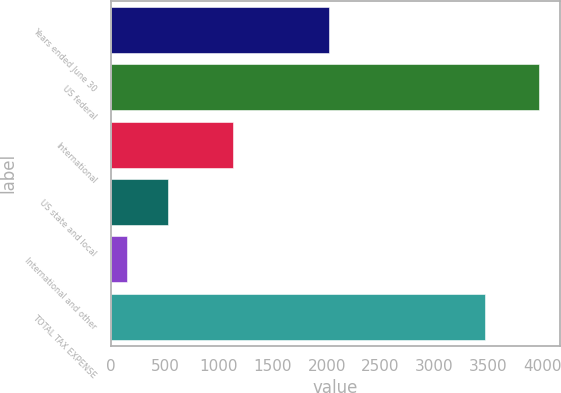Convert chart. <chart><loc_0><loc_0><loc_500><loc_500><bar_chart><fcel>Years ended June 30<fcel>US federal<fcel>International<fcel>US state and local<fcel>International and other<fcel>TOTAL TAX EXPENSE<nl><fcel>2018<fcel>3965<fcel>1131<fcel>527<fcel>145<fcel>3465<nl></chart> 